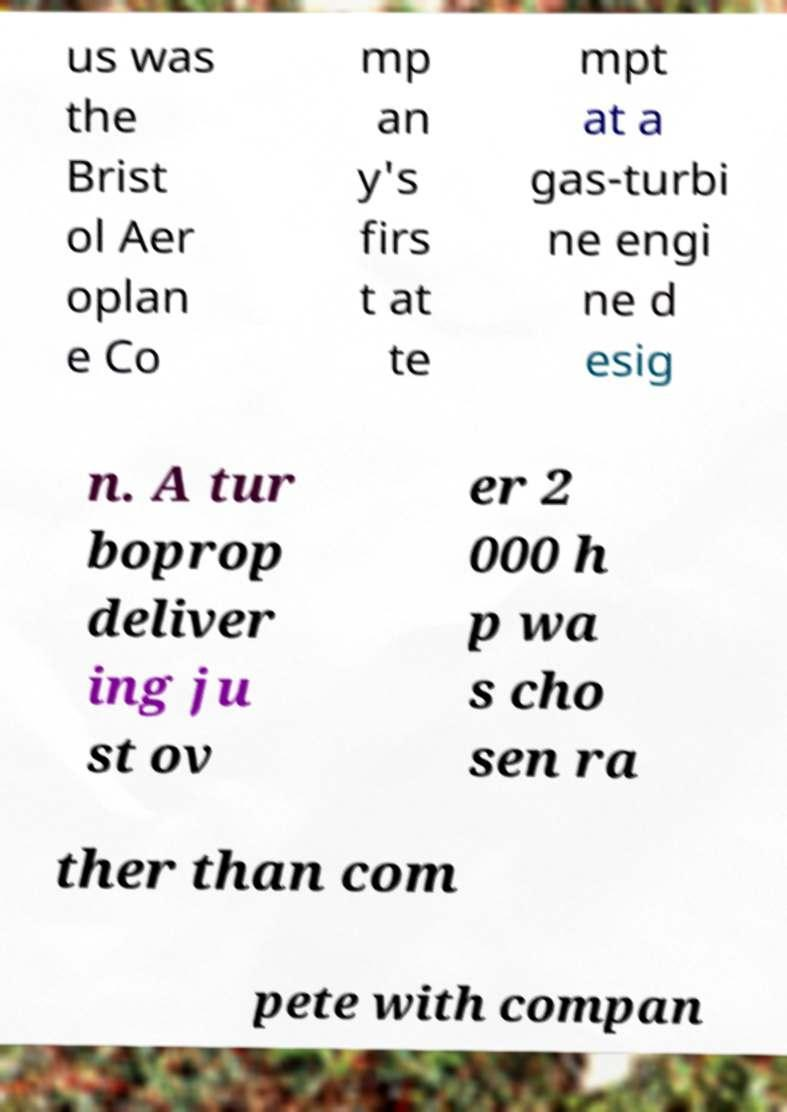I need the written content from this picture converted into text. Can you do that? us was the Brist ol Aer oplan e Co mp an y's firs t at te mpt at a gas-turbi ne engi ne d esig n. A tur boprop deliver ing ju st ov er 2 000 h p wa s cho sen ra ther than com pete with compan 